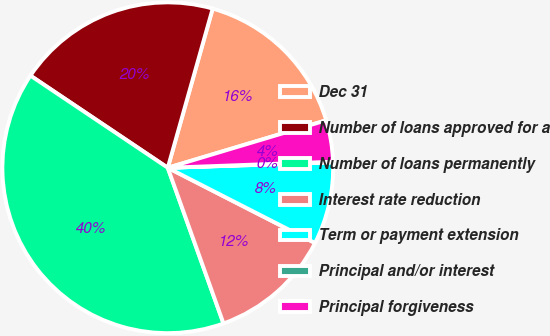<chart> <loc_0><loc_0><loc_500><loc_500><pie_chart><fcel>Dec 31<fcel>Number of loans approved for a<fcel>Number of loans permanently<fcel>Interest rate reduction<fcel>Term or payment extension<fcel>Principal and/or interest<fcel>Principal forgiveness<nl><fcel>15.99%<fcel>19.97%<fcel>39.87%<fcel>12.01%<fcel>8.03%<fcel>0.07%<fcel>4.05%<nl></chart> 